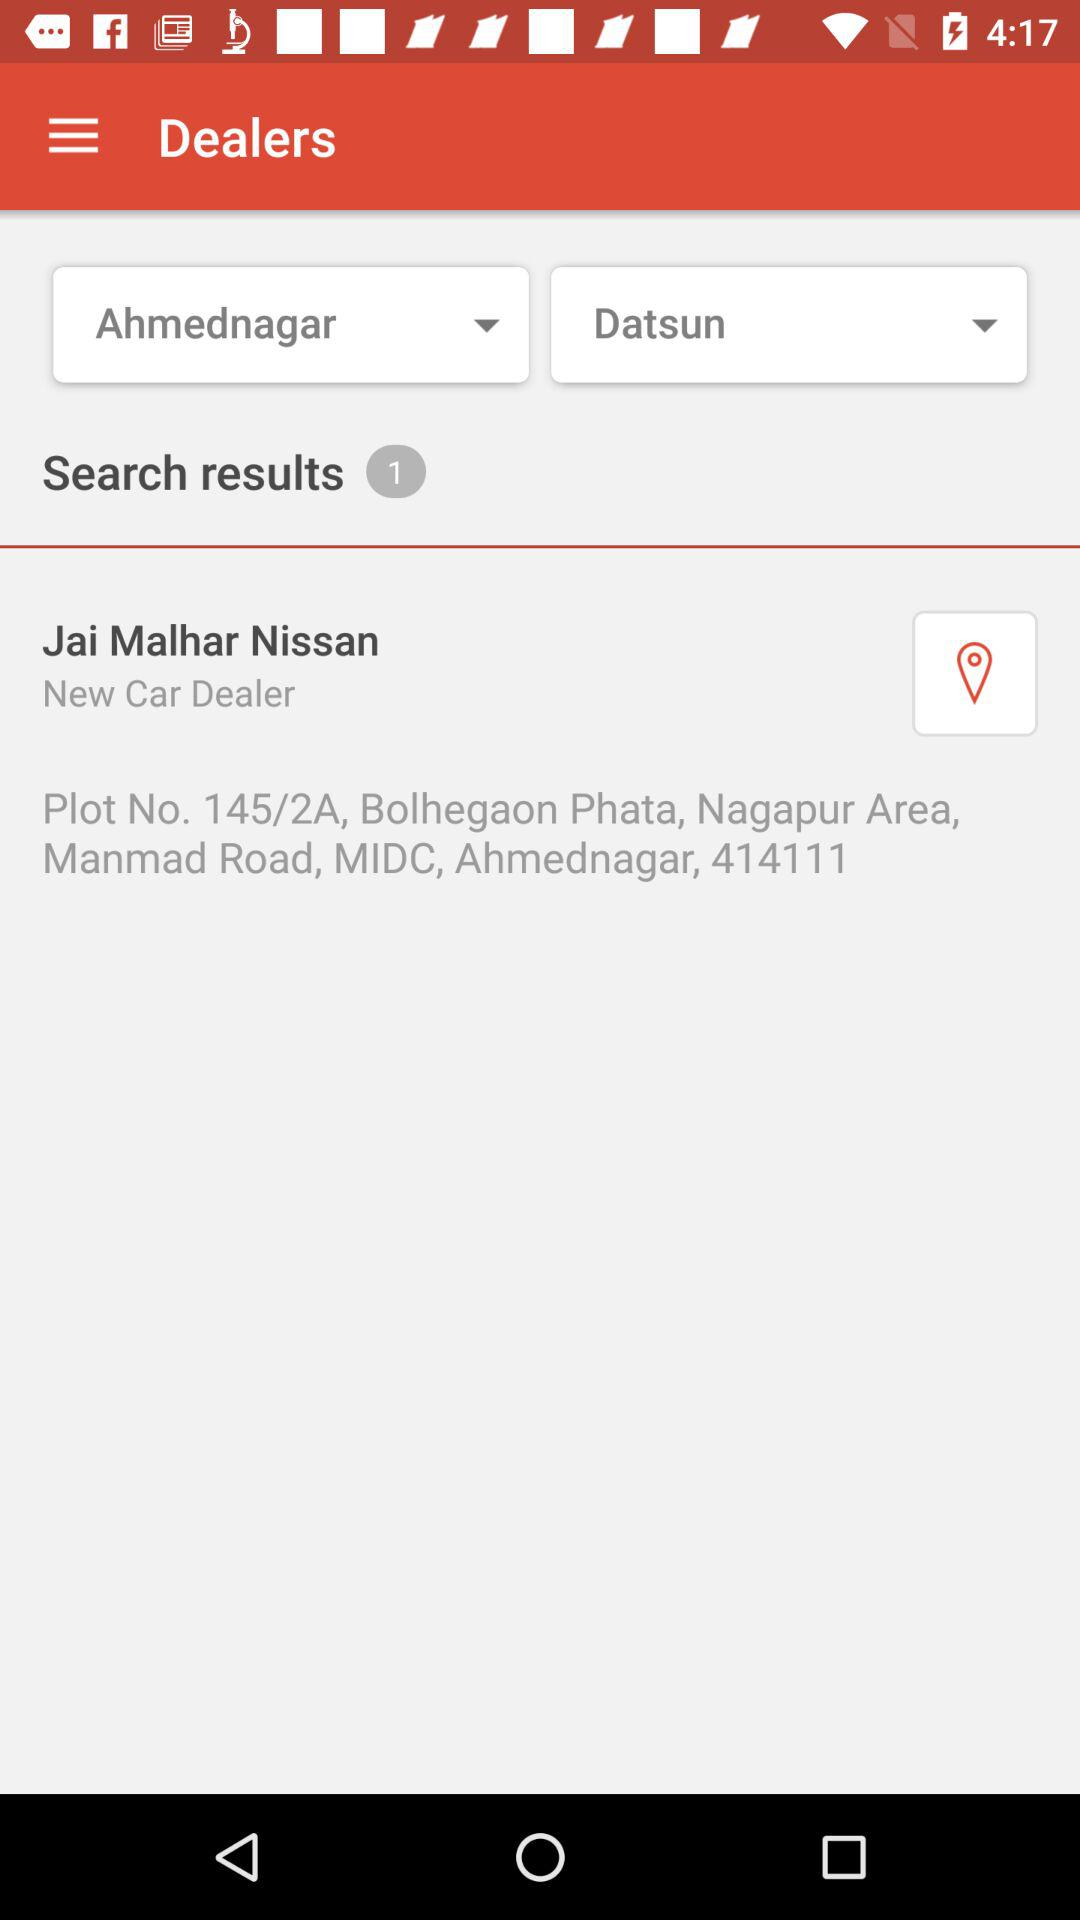What is the location of the first dealer in the search results?
Answer the question using a single word or phrase. Plot No. 145/2A, Bolhegaon Phata, Nagapur Area, Manmad Road, MIDC, Ahmednagar, 414111 